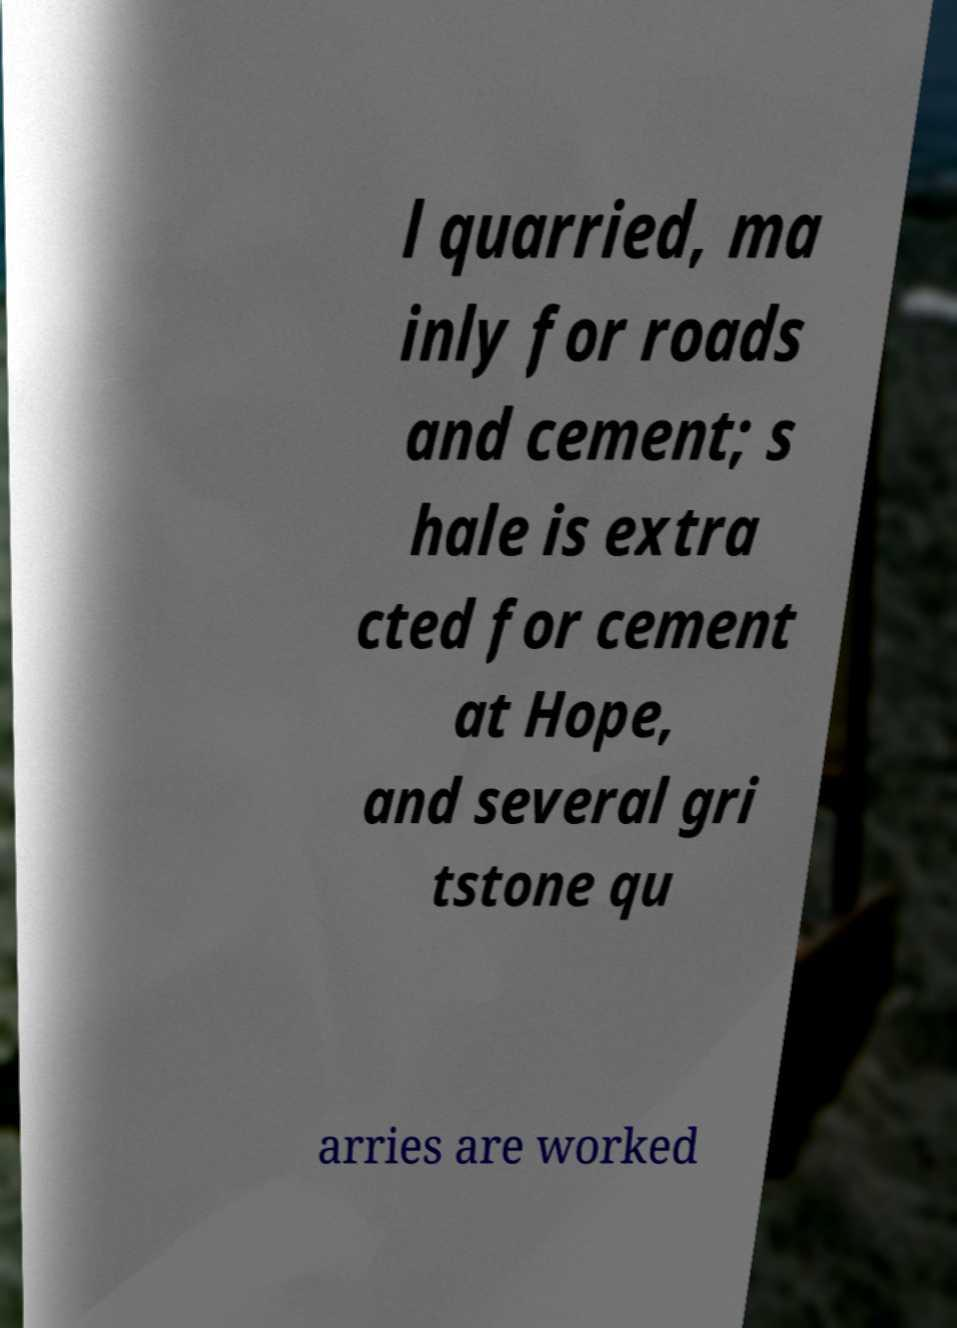Please read and relay the text visible in this image. What does it say? l quarried, ma inly for roads and cement; s hale is extra cted for cement at Hope, and several gri tstone qu arries are worked 